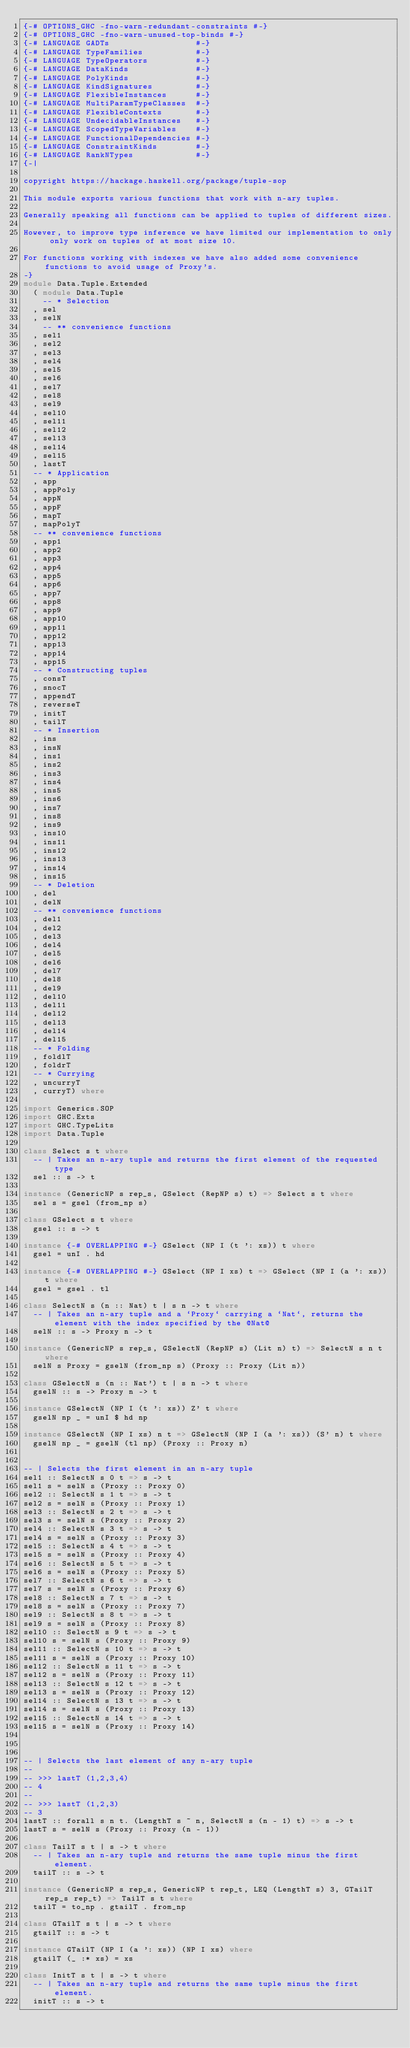Convert code to text. <code><loc_0><loc_0><loc_500><loc_500><_Haskell_>{-# OPTIONS_GHC -fno-warn-redundant-constraints #-}
{-# OPTIONS_GHC -fno-warn-unused-top-binds #-}
{-# LANGUAGE GADTs                  #-}
{-# LANGUAGE TypeFamilies           #-}
{-# LANGUAGE TypeOperators          #-}
{-# LANGUAGE DataKinds              #-}
{-# LANGUAGE PolyKinds              #-}
{-# LANGUAGE KindSignatures         #-}
{-# LANGUAGE FlexibleInstances      #-}
{-# LANGUAGE MultiParamTypeClasses  #-}
{-# LANGUAGE FlexibleContexts       #-}
{-# LANGUAGE UndecidableInstances   #-}
{-# LANGUAGE ScopedTypeVariables    #-}
{-# LANGUAGE FunctionalDependencies #-}
{-# LANGUAGE ConstraintKinds        #-}
{-# LANGUAGE RankNTypes             #-}
{-|

copyright https://hackage.haskell.org/package/tuple-sop

This module exports various functions that work with n-ary tuples.

Generally speaking all functions can be applied to tuples of different sizes.

However, to improve type inference we have limited our implementation to only only work on tuples of at most size 10.

For functions working with indexes we have also added some convenience functions to avoid usage of Proxy's.
-}
module Data.Tuple.Extended
  ( module Data.Tuple
    -- * Selection
  , sel
  , selN
    -- ** convenience functions 
  , sel1
  , sel2
  , sel3
  , sel4
  , sel5
  , sel6
  , sel7
  , sel8
  , sel9
  , sel10
  , sel11
  , sel12
  , sel13
  , sel14
  , sel15
  , lastT
  -- * Application
  , app
  , appPoly
  , appN
  , appF
  , mapT
  , mapPolyT
  -- ** convenience functions 
  , app1
  , app2
  , app3
  , app4
  , app5
  , app6
  , app7
  , app8
  , app9
  , app10
  , app11
  , app12
  , app13
  , app14
  , app15  
  -- * Constructing tuples
  , consT
  , snocT
  , appendT
  , reverseT
  , initT
  , tailT
  -- * Insertion
  , ins
  , insN
  , ins1
  , ins2
  , ins3
  , ins4
  , ins5
  , ins6
  , ins7
  , ins8
  , ins9
  , ins10
  , ins11
  , ins12
  , ins13
  , ins14
  , ins15  
  -- * Deletion
  , del
  , delN
  -- ** convenience functions
  , del1
  , del2
  , del3
  , del4
  , del5
  , del6
  , del7
  , del8
  , del9
  , del10
  , del11
  , del12
  , del13
  , del14
  , del15  
  -- * Folding
  , foldlT
  , foldrT
  -- * Currying
  , uncurryT
  , curryT) where

import Generics.SOP
import GHC.Exts
import GHC.TypeLits
import Data.Tuple

class Select s t where
  -- | Takes an n-ary tuple and returns the first element of the requested type
  sel :: s -> t

instance (GenericNP s rep_s, GSelect (RepNP s) t) => Select s t where
  sel s = gsel (from_np s)

class GSelect s t where
  gsel :: s -> t

instance {-# OVERLAPPING #-} GSelect (NP I (t ': xs)) t where
  gsel = unI . hd

instance {-# OVERLAPPING #-} GSelect (NP I xs) t => GSelect (NP I (a ': xs)) t where
  gsel = gsel . tl

class SelectN s (n :: Nat) t | s n -> t where
  -- | Takes an n-ary tuple and a `Proxy` carrying a `Nat`, returns the element with the index specified by the @Nat@
  selN :: s -> Proxy n -> t

instance (GenericNP s rep_s, GSelectN (RepNP s) (Lit n) t) => SelectN s n t where
  selN s Proxy = gselN (from_np s) (Proxy :: Proxy (Lit n))

class GSelectN s (n :: Nat') t | s n -> t where
  gselN :: s -> Proxy n -> t

instance GSelectN (NP I (t ': xs)) Z' t where
  gselN np _ = unI $ hd np

instance GSelectN (NP I xs) n t => GSelectN (NP I (a ': xs)) (S' n) t where
  gselN np _ = gselN (tl np) (Proxy :: Proxy n)


-- | Selects the first element in an n-ary tuple
sel1 :: SelectN s 0 t => s -> t
sel1 s = selN s (Proxy :: Proxy 0)
sel2 :: SelectN s 1 t => s -> t
sel2 s = selN s (Proxy :: Proxy 1)
sel3 :: SelectN s 2 t => s -> t
sel3 s = selN s (Proxy :: Proxy 2)
sel4 :: SelectN s 3 t => s -> t
sel4 s = selN s (Proxy :: Proxy 3)
sel5 :: SelectN s 4 t => s -> t
sel5 s = selN s (Proxy :: Proxy 4)
sel6 :: SelectN s 5 t => s -> t
sel6 s = selN s (Proxy :: Proxy 5)
sel7 :: SelectN s 6 t => s -> t
sel7 s = selN s (Proxy :: Proxy 6)
sel8 :: SelectN s 7 t => s -> t
sel8 s = selN s (Proxy :: Proxy 7)
sel9 :: SelectN s 8 t => s -> t
sel9 s = selN s (Proxy :: Proxy 8)
sel10 :: SelectN s 9 t => s -> t
sel10 s = selN s (Proxy :: Proxy 9)
sel11 :: SelectN s 10 t => s -> t
sel11 s = selN s (Proxy :: Proxy 10)
sel12 :: SelectN s 11 t => s -> t
sel12 s = selN s (Proxy :: Proxy 11)
sel13 :: SelectN s 12 t => s -> t
sel13 s = selN s (Proxy :: Proxy 12)
sel14 :: SelectN s 13 t => s -> t
sel14 s = selN s (Proxy :: Proxy 13)
sel15 :: SelectN s 14 t => s -> t
sel15 s = selN s (Proxy :: Proxy 14)



-- | Selects the last element of any n-ary tuple
--
-- >>> lastT (1,2,3,4)
-- 4
--
-- >>> lastT (1,2,3)
-- 3
lastT :: forall s n t. (LengthT s ~ n, SelectN s (n - 1) t) => s -> t
lastT s = selN s (Proxy :: Proxy (n - 1))

class TailT s t | s -> t where
  -- | Takes an n-ary tuple and returns the same tuple minus the first element.
  tailT :: s -> t

instance (GenericNP s rep_s, GenericNP t rep_t, LEQ (LengthT s) 3, GTailT rep_s rep_t) => TailT s t where
  tailT = to_np . gtailT . from_np
  
class GTailT s t | s -> t where
  gtailT :: s -> t

instance GTailT (NP I (a ': xs)) (NP I xs) where
  gtailT (_ :* xs) = xs

class InitT s t | s -> t where
  -- | Takes an n-ary tuple and returns the same tuple minus the first element.
  initT :: s -> t
</code> 